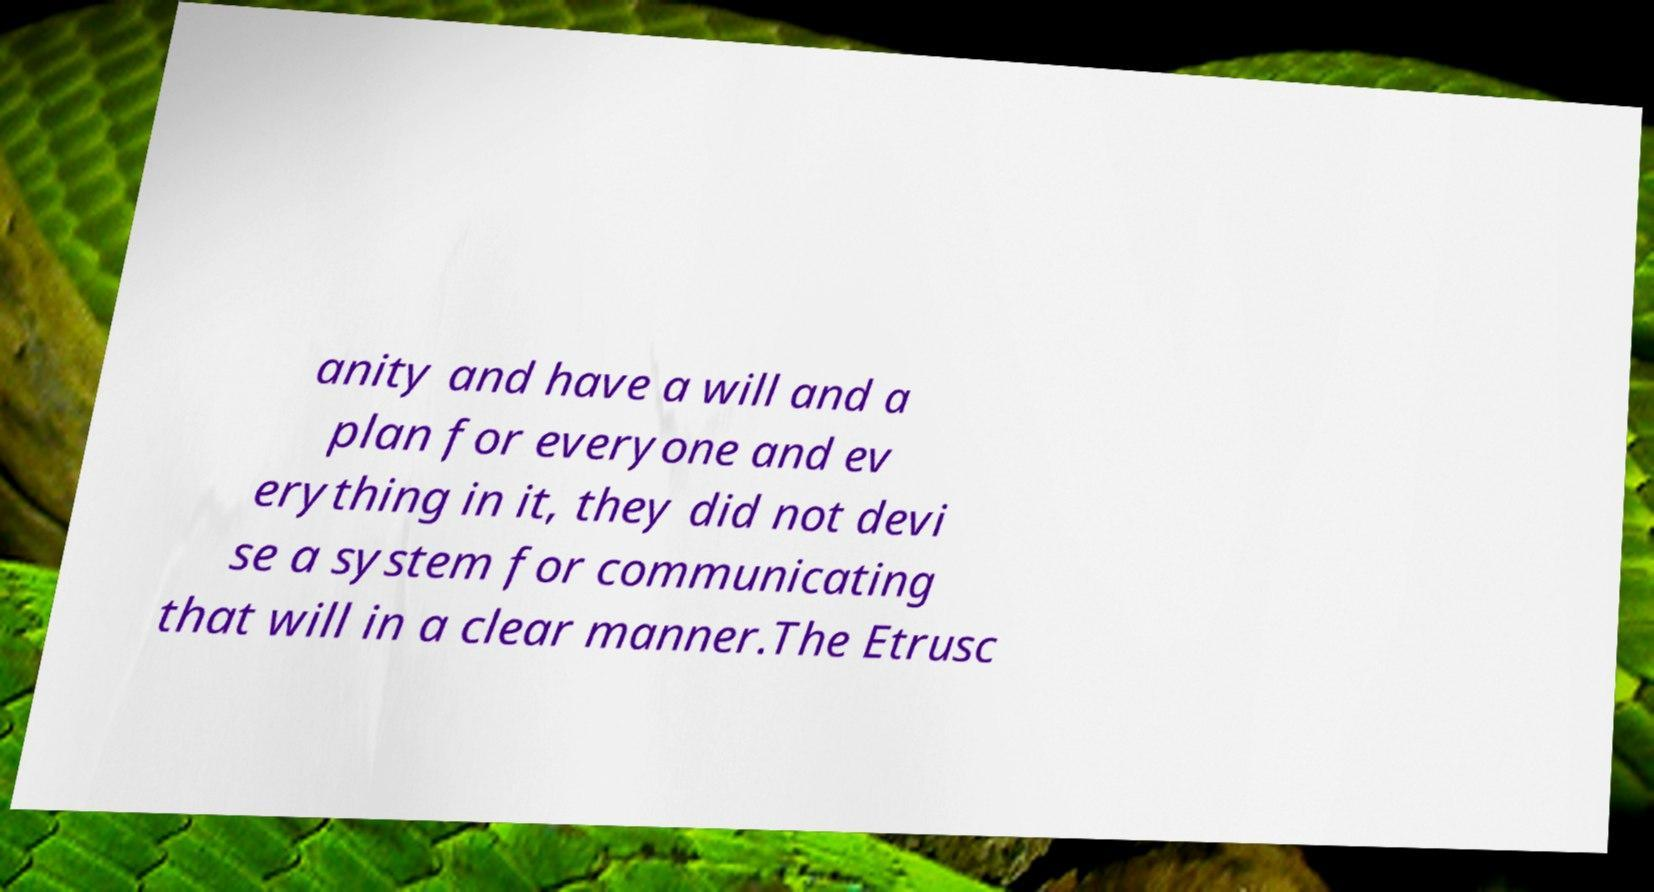Please read and relay the text visible in this image. What does it say? anity and have a will and a plan for everyone and ev erything in it, they did not devi se a system for communicating that will in a clear manner.The Etrusc 